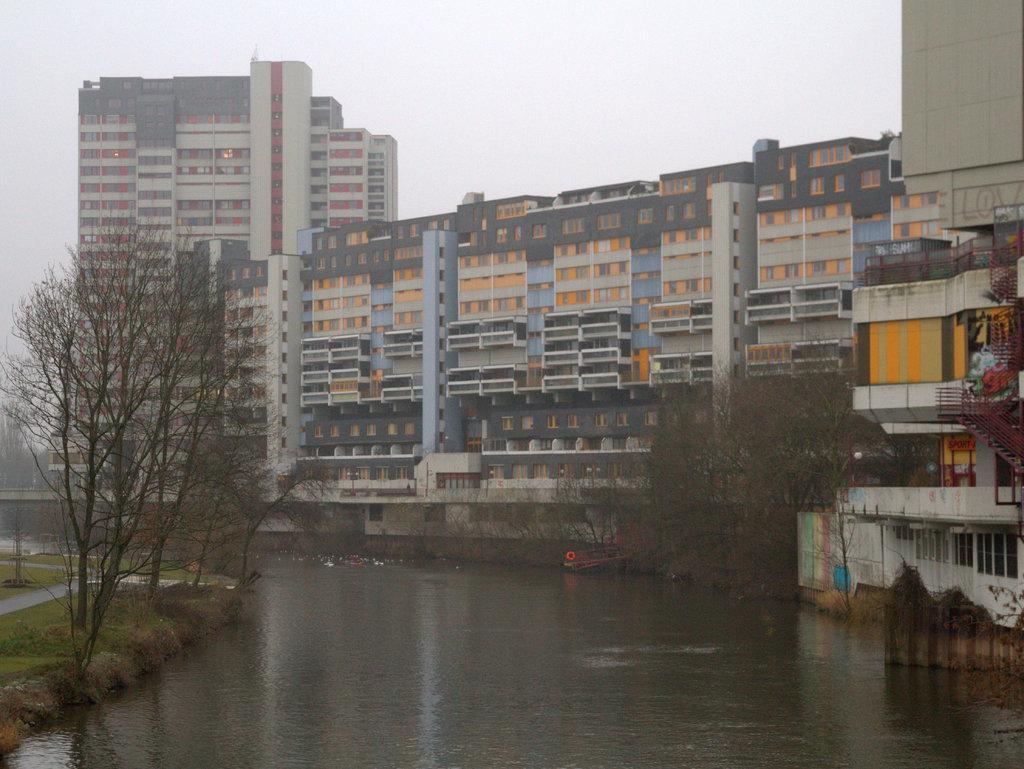Can you describe this image briefly? In this image we can see trees, water, grass, road, stairs and sky. 